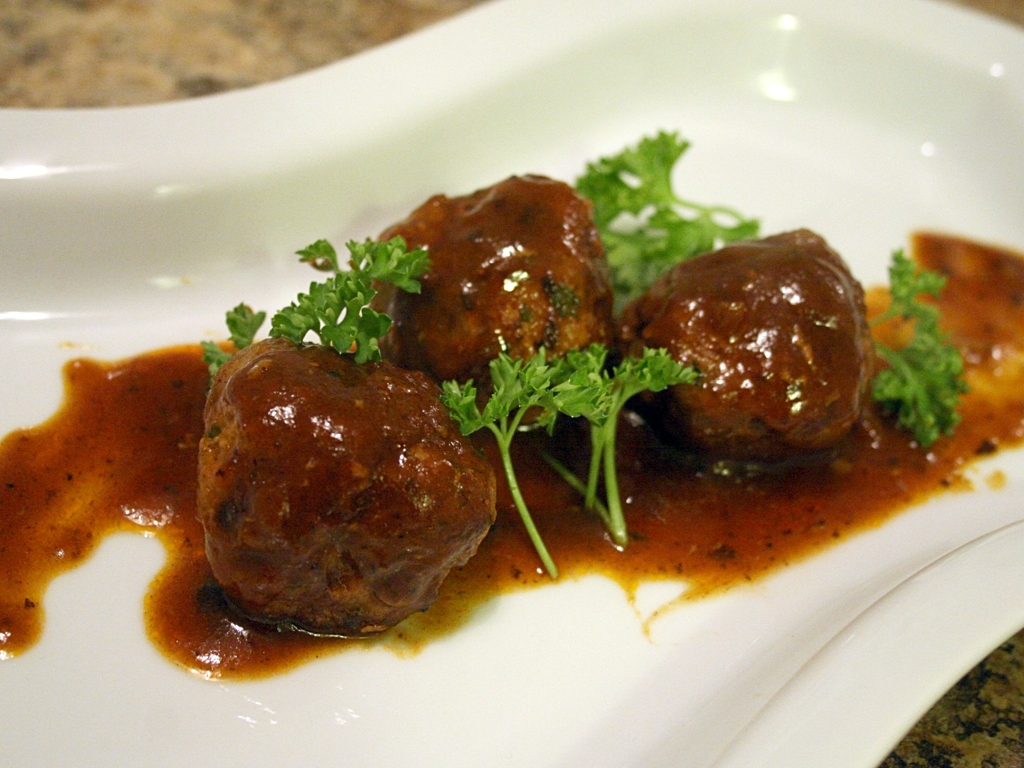Is the main subject (food) clear in the image? Yes, the main subject of the image, which appears to be meatballs in a savory sauce garnished with parsley, is presented in a clear and appetizing manner. The focus is sharp, and the plating is simple, allowing the viewer to easily identify the dish as the central element of the photograph. 